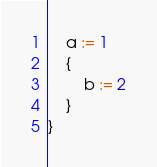<code> <loc_0><loc_0><loc_500><loc_500><_Go_>	a := 1
	{
		b := 2
	}
}
</code> 